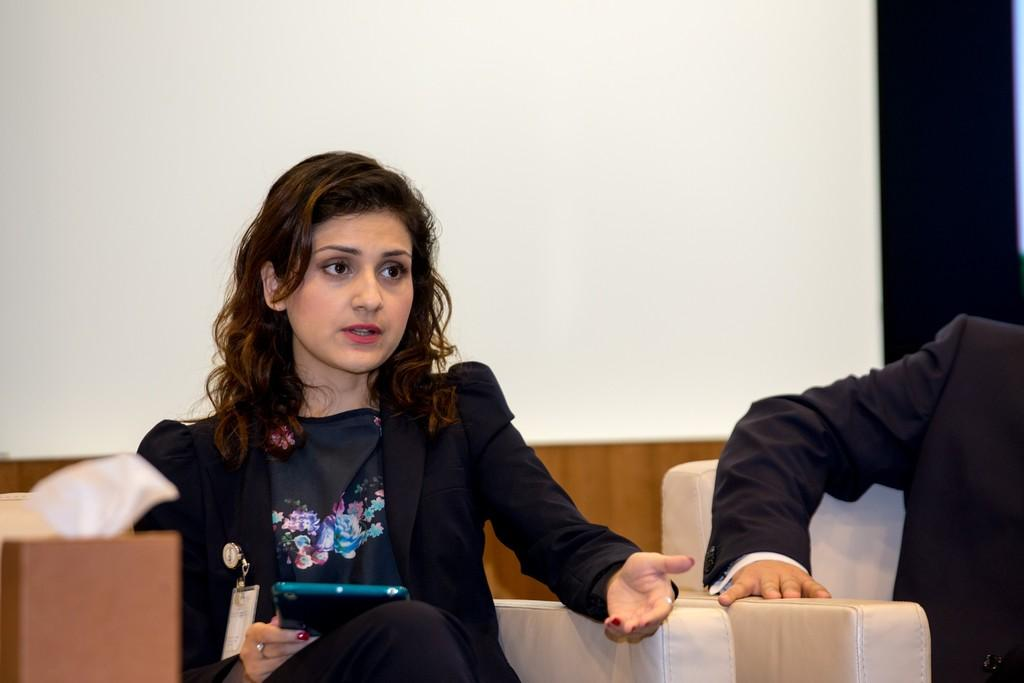How many people are in the image? There are people in the image, but the exact number is not specified. What are the people in the image doing? The people in the image are seated. Can you describe any objects that the people are holding? One person is holding a tablet. What type of pickle is being served for dinner in the image? There is no mention of pickles or dinner in the image; it only shows people seated with one person holding a tablet. 